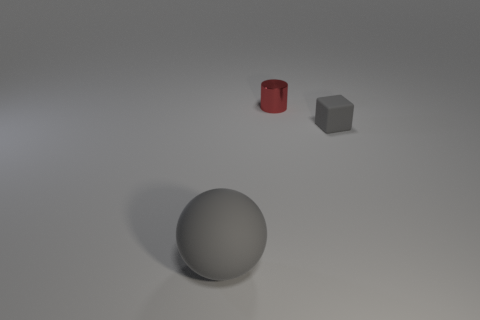Add 3 big yellow matte cylinders. How many objects exist? 6 Subtract 0 purple cylinders. How many objects are left? 3 Subtract all matte blocks. Subtract all big gray rubber spheres. How many objects are left? 1 Add 3 cylinders. How many cylinders are left? 4 Add 3 cylinders. How many cylinders exist? 4 